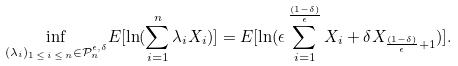<formula> <loc_0><loc_0><loc_500><loc_500>\underset { ( \lambda _ { i } ) _ { 1 \, \leq \, i \, \leq \, n } \in \mathcal { P } _ { n } ^ { \epsilon , \delta } } { \inf } E [ \ln ( \sum _ { i = 1 } ^ { n } \lambda _ { i } X _ { i } ) ] = E [ \ln ( \epsilon \sum _ { i = 1 } ^ { \frac { ( 1 - \delta ) } { \epsilon } } X _ { i } + \delta X _ { \frac { ( 1 - \delta ) } { \epsilon } + 1 } ) ] .</formula> 